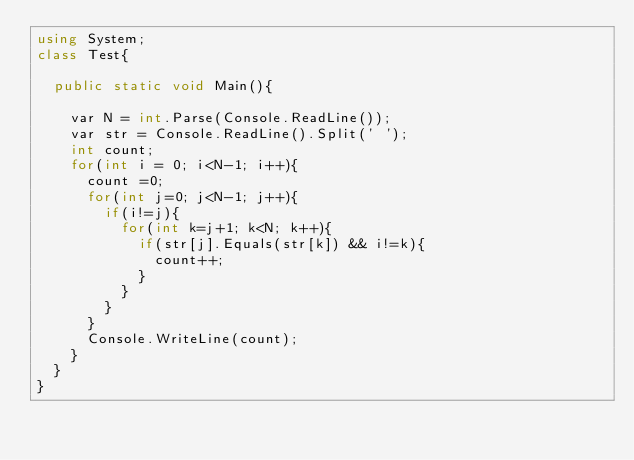<code> <loc_0><loc_0><loc_500><loc_500><_C#_>using System;
class Test{
 
  public static void Main(){
    
    var N = int.Parse(Console.ReadLine());
    var str = Console.ReadLine().Split(' ');
    int count;
    for(int i = 0; i<N-1; i++){
      count =0;
      for(int j=0; j<N-1; j++){
        if(i!=j){
          for(int k=j+1; k<N; k++){
            if(str[j].Equals(str[k]) && i!=k){
              count++;
            }
          } 
        }
      }
      Console.WriteLine(count);
    }
  }
}</code> 